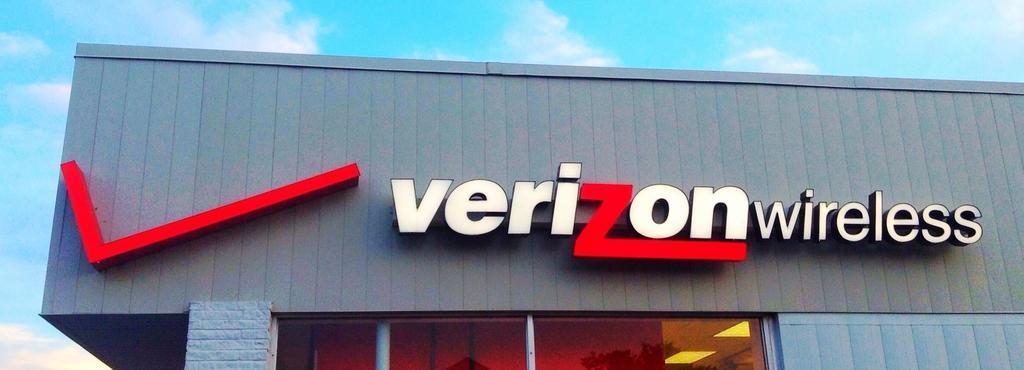How would you summarize this image in a sentence or two? In the image there is a company name in front of the organization. 